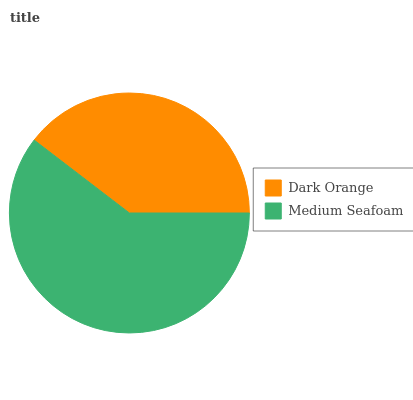Is Dark Orange the minimum?
Answer yes or no. Yes. Is Medium Seafoam the maximum?
Answer yes or no. Yes. Is Medium Seafoam the minimum?
Answer yes or no. No. Is Medium Seafoam greater than Dark Orange?
Answer yes or no. Yes. Is Dark Orange less than Medium Seafoam?
Answer yes or no. Yes. Is Dark Orange greater than Medium Seafoam?
Answer yes or no. No. Is Medium Seafoam less than Dark Orange?
Answer yes or no. No. Is Medium Seafoam the high median?
Answer yes or no. Yes. Is Dark Orange the low median?
Answer yes or no. Yes. Is Dark Orange the high median?
Answer yes or no. No. Is Medium Seafoam the low median?
Answer yes or no. No. 